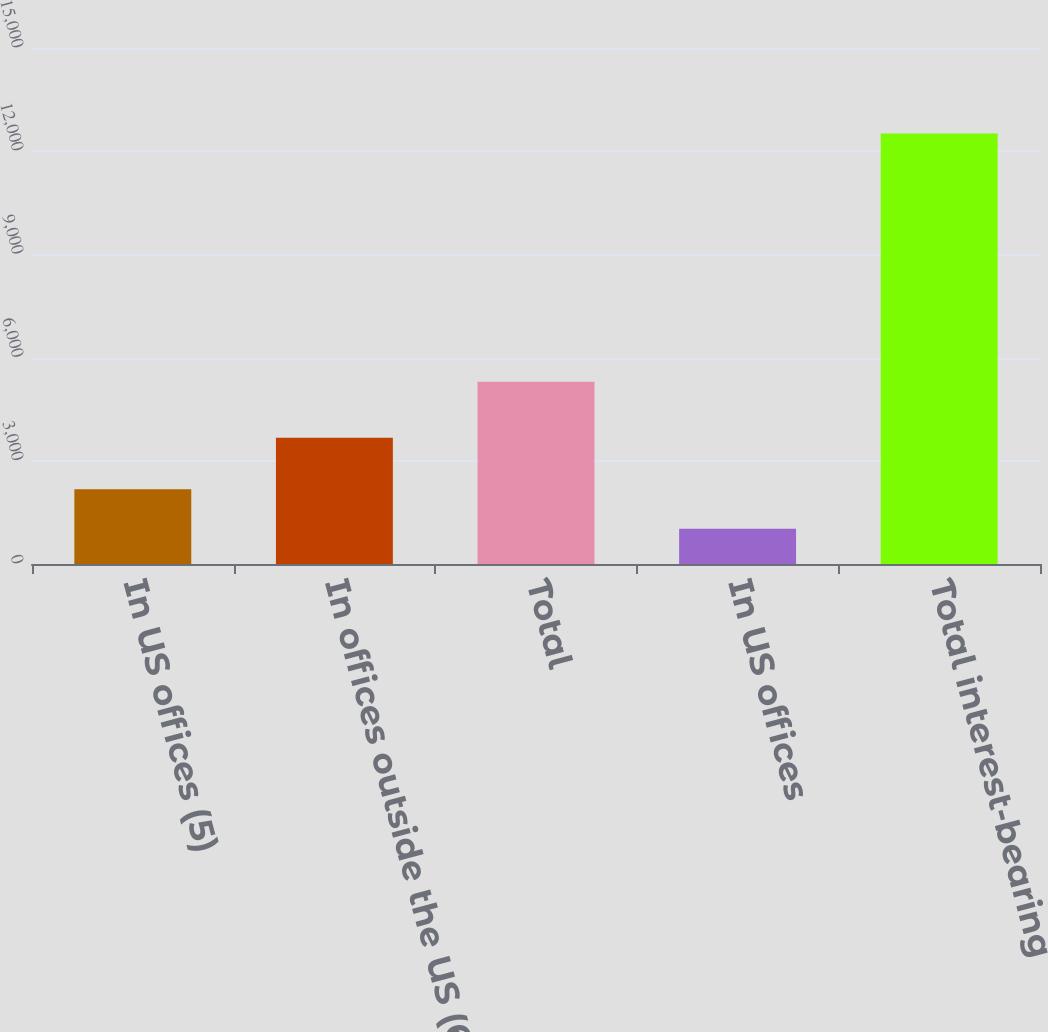Convert chart. <chart><loc_0><loc_0><loc_500><loc_500><bar_chart><fcel>In US offices (5)<fcel>In offices outside the US (6)<fcel>Total<fcel>In US offices<fcel>Total interest-bearing<nl><fcel>2172.7<fcel>3670<fcel>5300<fcel>1024<fcel>12511<nl></chart> 